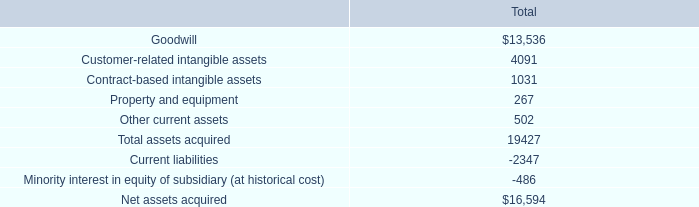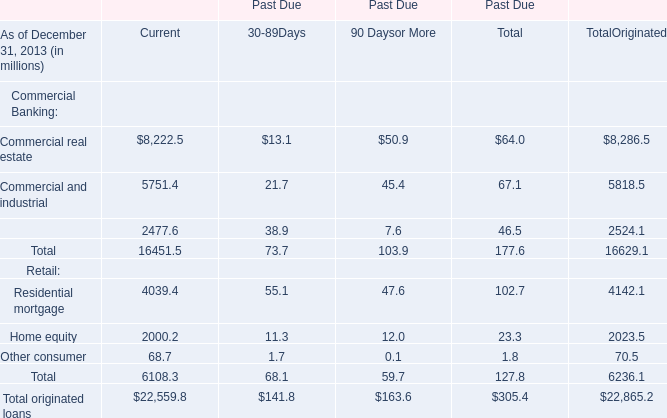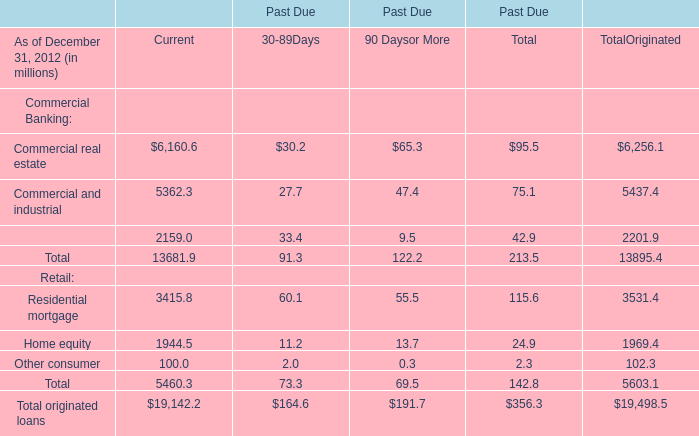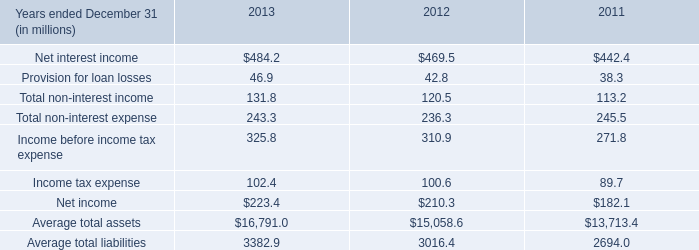what percent of assets acquired by the acquisition are non-tangible assets? 
Computations: (((13536 + 4091) + 1031) / 19427)
Answer: 0.96042. 